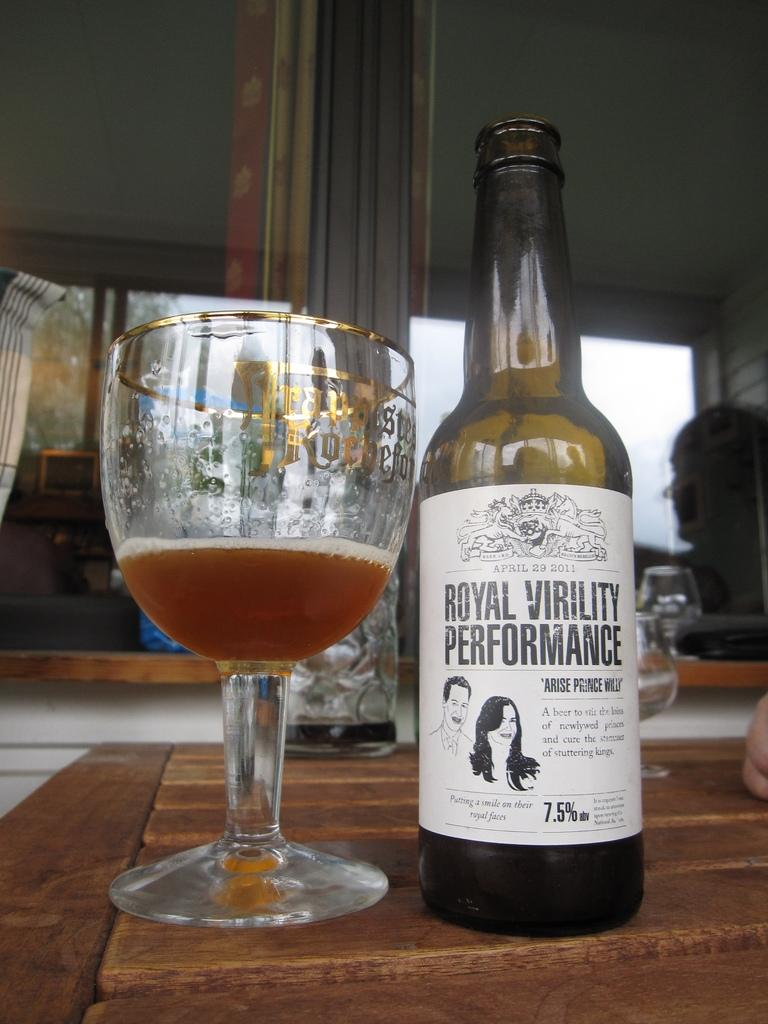What object is located on the right side of the image? There is a bottle on the right side of the image. What object is located on the left side of the image? There is a glass with a drink on the left side of the image. What can be seen in the background of the image? There is a window and a wall in the background of the image. What type of sweater is being used as a vessel for the drink in the image? There is no sweater present in the image, nor is it being used as a vessel for the drink. 